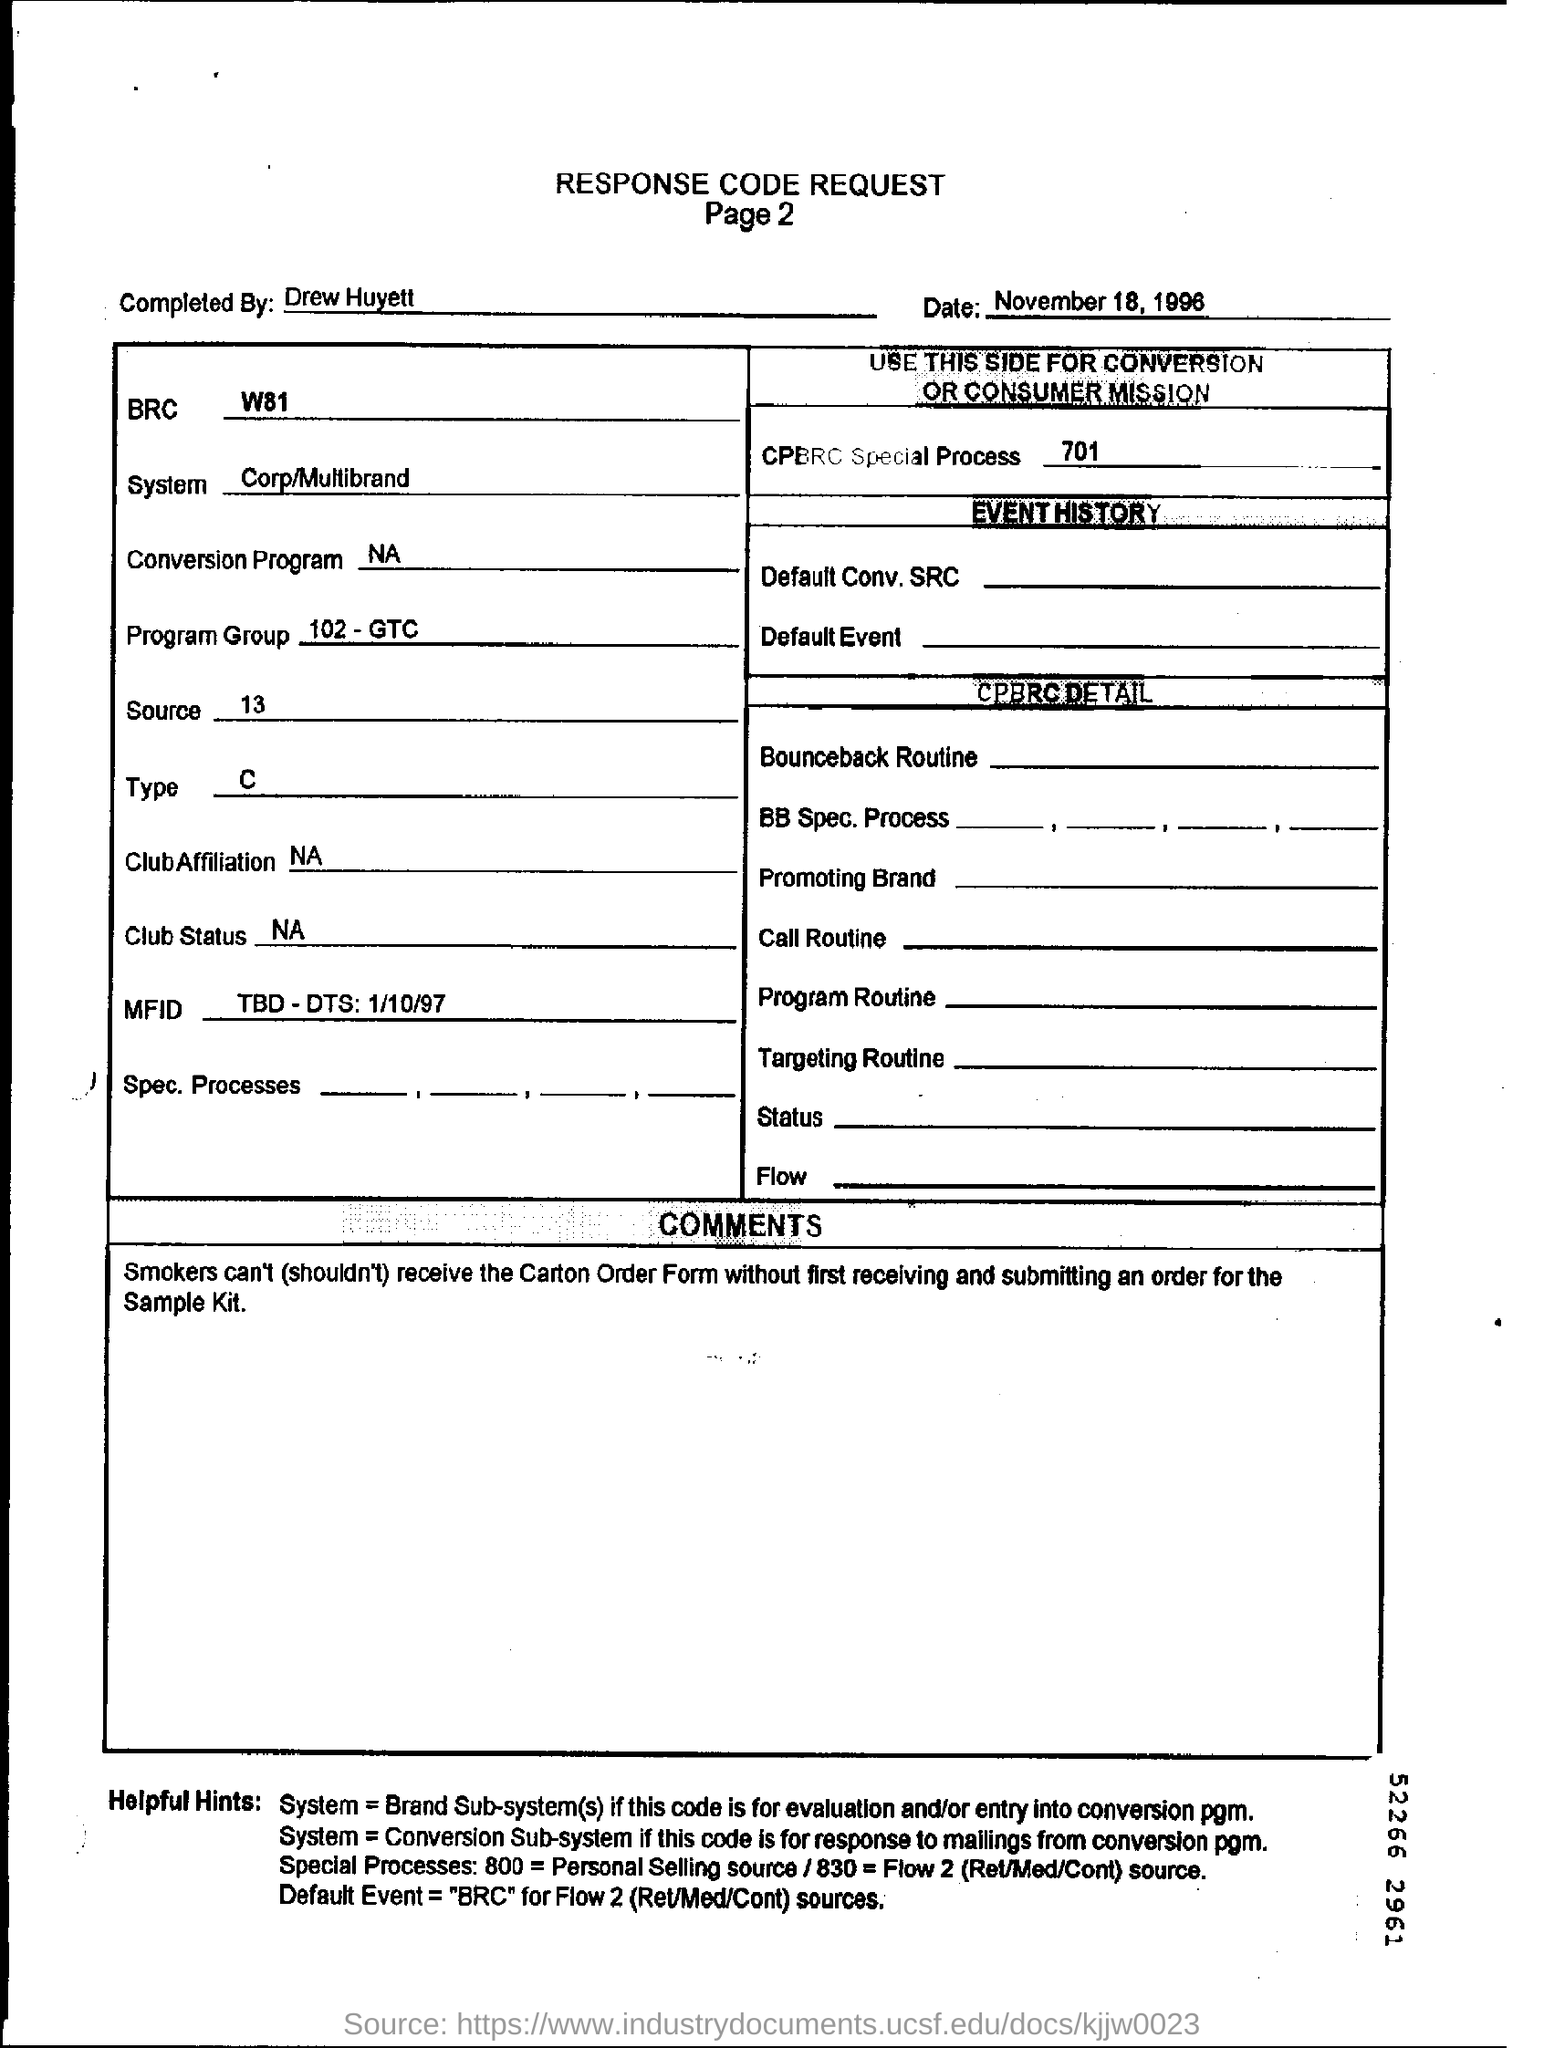Mention a couple of crucial points in this snapshot. This document was completed by Drew Huyett. The BRC mentioned is W81. 